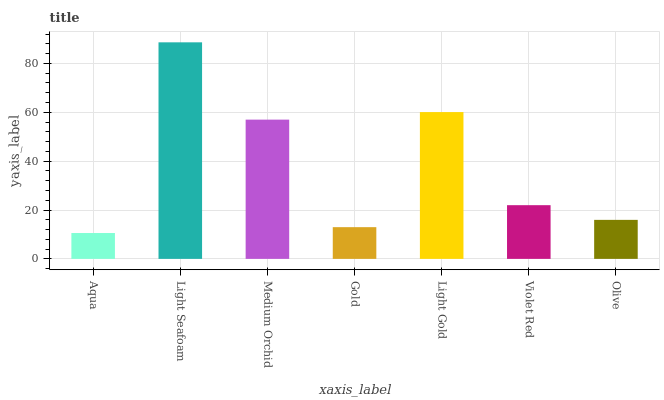Is Aqua the minimum?
Answer yes or no. Yes. Is Light Seafoam the maximum?
Answer yes or no. Yes. Is Medium Orchid the minimum?
Answer yes or no. No. Is Medium Orchid the maximum?
Answer yes or no. No. Is Light Seafoam greater than Medium Orchid?
Answer yes or no. Yes. Is Medium Orchid less than Light Seafoam?
Answer yes or no. Yes. Is Medium Orchid greater than Light Seafoam?
Answer yes or no. No. Is Light Seafoam less than Medium Orchid?
Answer yes or no. No. Is Violet Red the high median?
Answer yes or no. Yes. Is Violet Red the low median?
Answer yes or no. Yes. Is Light Gold the high median?
Answer yes or no. No. Is Olive the low median?
Answer yes or no. No. 